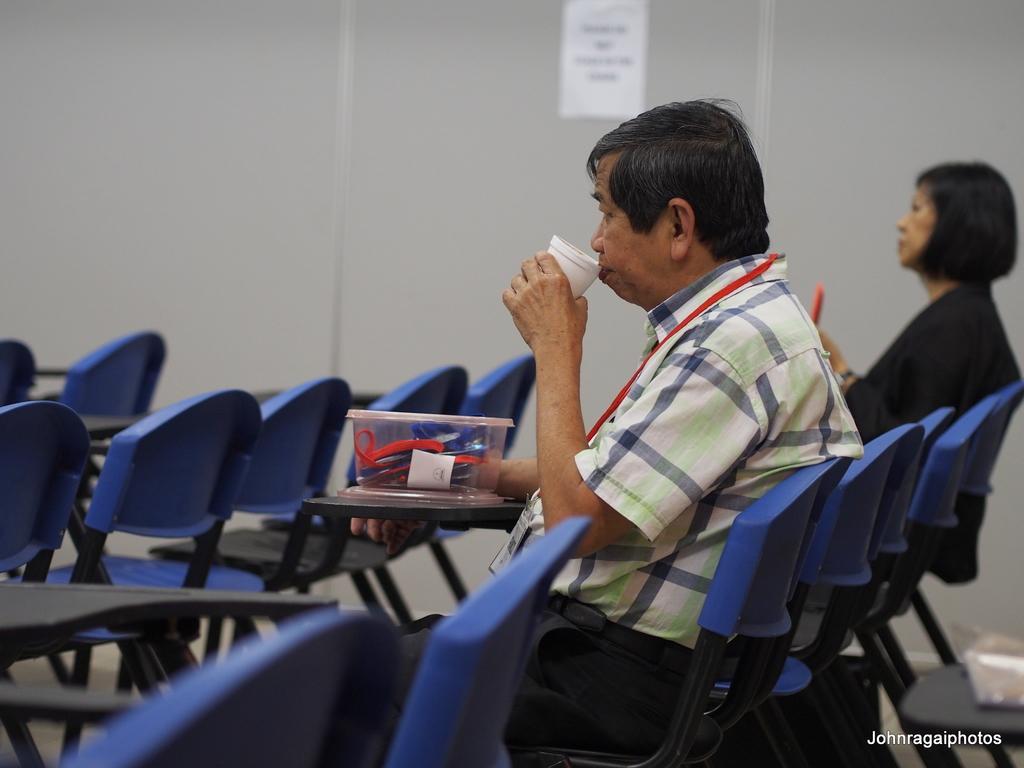Can you describe this image briefly? In this picture we can see man and woman sitting on chairs and here man drinking with cup and in front of them we have box, chairs and beside to the wall with sticker. 